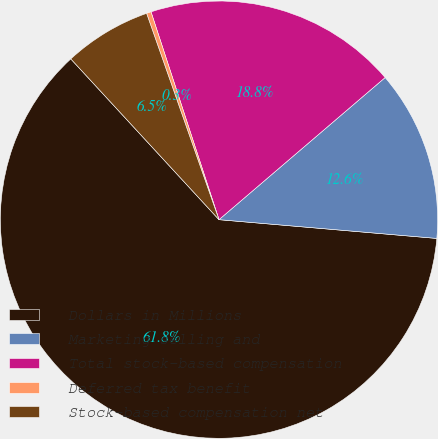Convert chart. <chart><loc_0><loc_0><loc_500><loc_500><pie_chart><fcel>Dollars in Millions<fcel>Marketing selling and<fcel>Total stock-based compensation<fcel>Deferred tax benefit<fcel>Stock-based compensation net<nl><fcel>61.78%<fcel>12.63%<fcel>18.77%<fcel>0.34%<fcel>6.48%<nl></chart> 